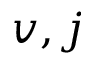Convert formula to latex. <formula><loc_0><loc_0><loc_500><loc_500>v , j</formula> 